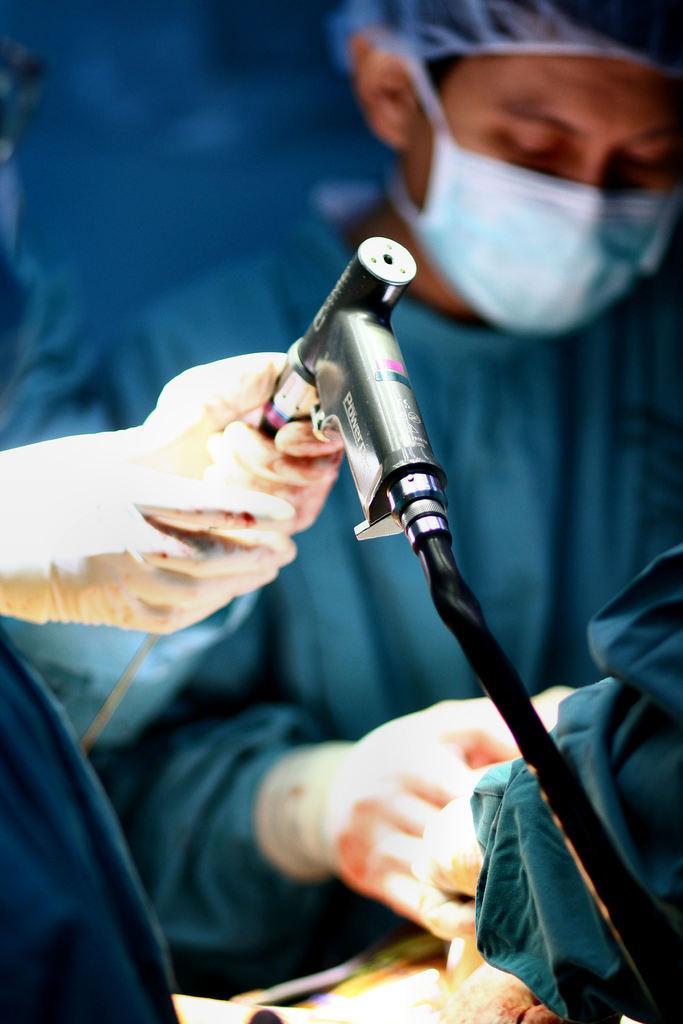In one or two sentences, can you explain what this image depicts? In this image we can see people. On the left we can see a person's hands holding an object. 